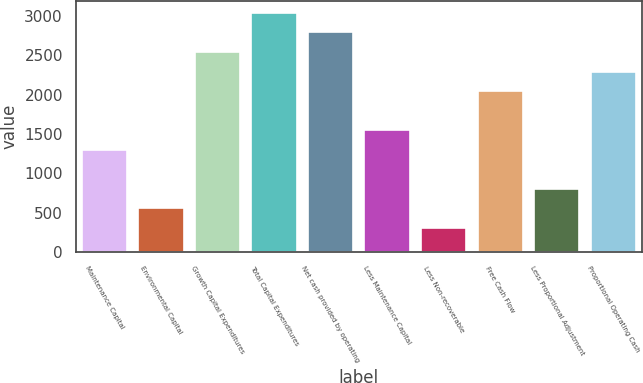Convert chart. <chart><loc_0><loc_0><loc_500><loc_500><bar_chart><fcel>Maintenance Capital<fcel>Environmental Capital<fcel>Growth Capital Expenditures<fcel>Total Capital Expenditures<fcel>Net cash provided by operating<fcel>Less Maintenance Capital<fcel>Less Non-recoverable<fcel>Free Cash Flow<fcel>Less Proportional Adjustment<fcel>Proportional Operating Cash<nl><fcel>1300<fcel>553.6<fcel>2544<fcel>3041.6<fcel>2792.8<fcel>1548.8<fcel>304.8<fcel>2046.4<fcel>802.4<fcel>2295.2<nl></chart> 